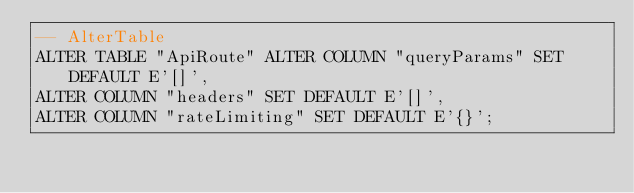<code> <loc_0><loc_0><loc_500><loc_500><_SQL_>-- AlterTable
ALTER TABLE "ApiRoute" ALTER COLUMN "queryParams" SET DEFAULT E'[]',
ALTER COLUMN "headers" SET DEFAULT E'[]',
ALTER COLUMN "rateLimiting" SET DEFAULT E'{}';
</code> 